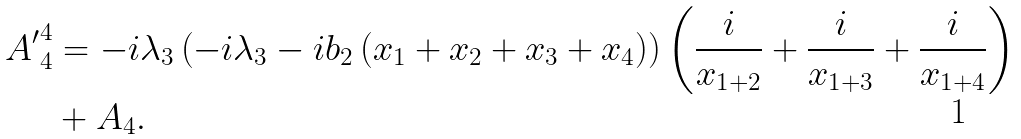Convert formula to latex. <formula><loc_0><loc_0><loc_500><loc_500>{ A ^ { \prime } } ^ { 4 } _ { 4 } & = - i \lambda _ { 3 } \left ( - i \lambda _ { 3 } - i b _ { 2 } \left ( x _ { 1 } + x _ { 2 } + x _ { 3 } + x _ { 4 } \right ) \right ) \left ( \frac { i } { x _ { 1 + 2 } } + \frac { i } { x _ { 1 + 3 } } + \frac { i } { x _ { 1 + 4 } } \right ) \\ & + A _ { 4 } .</formula> 